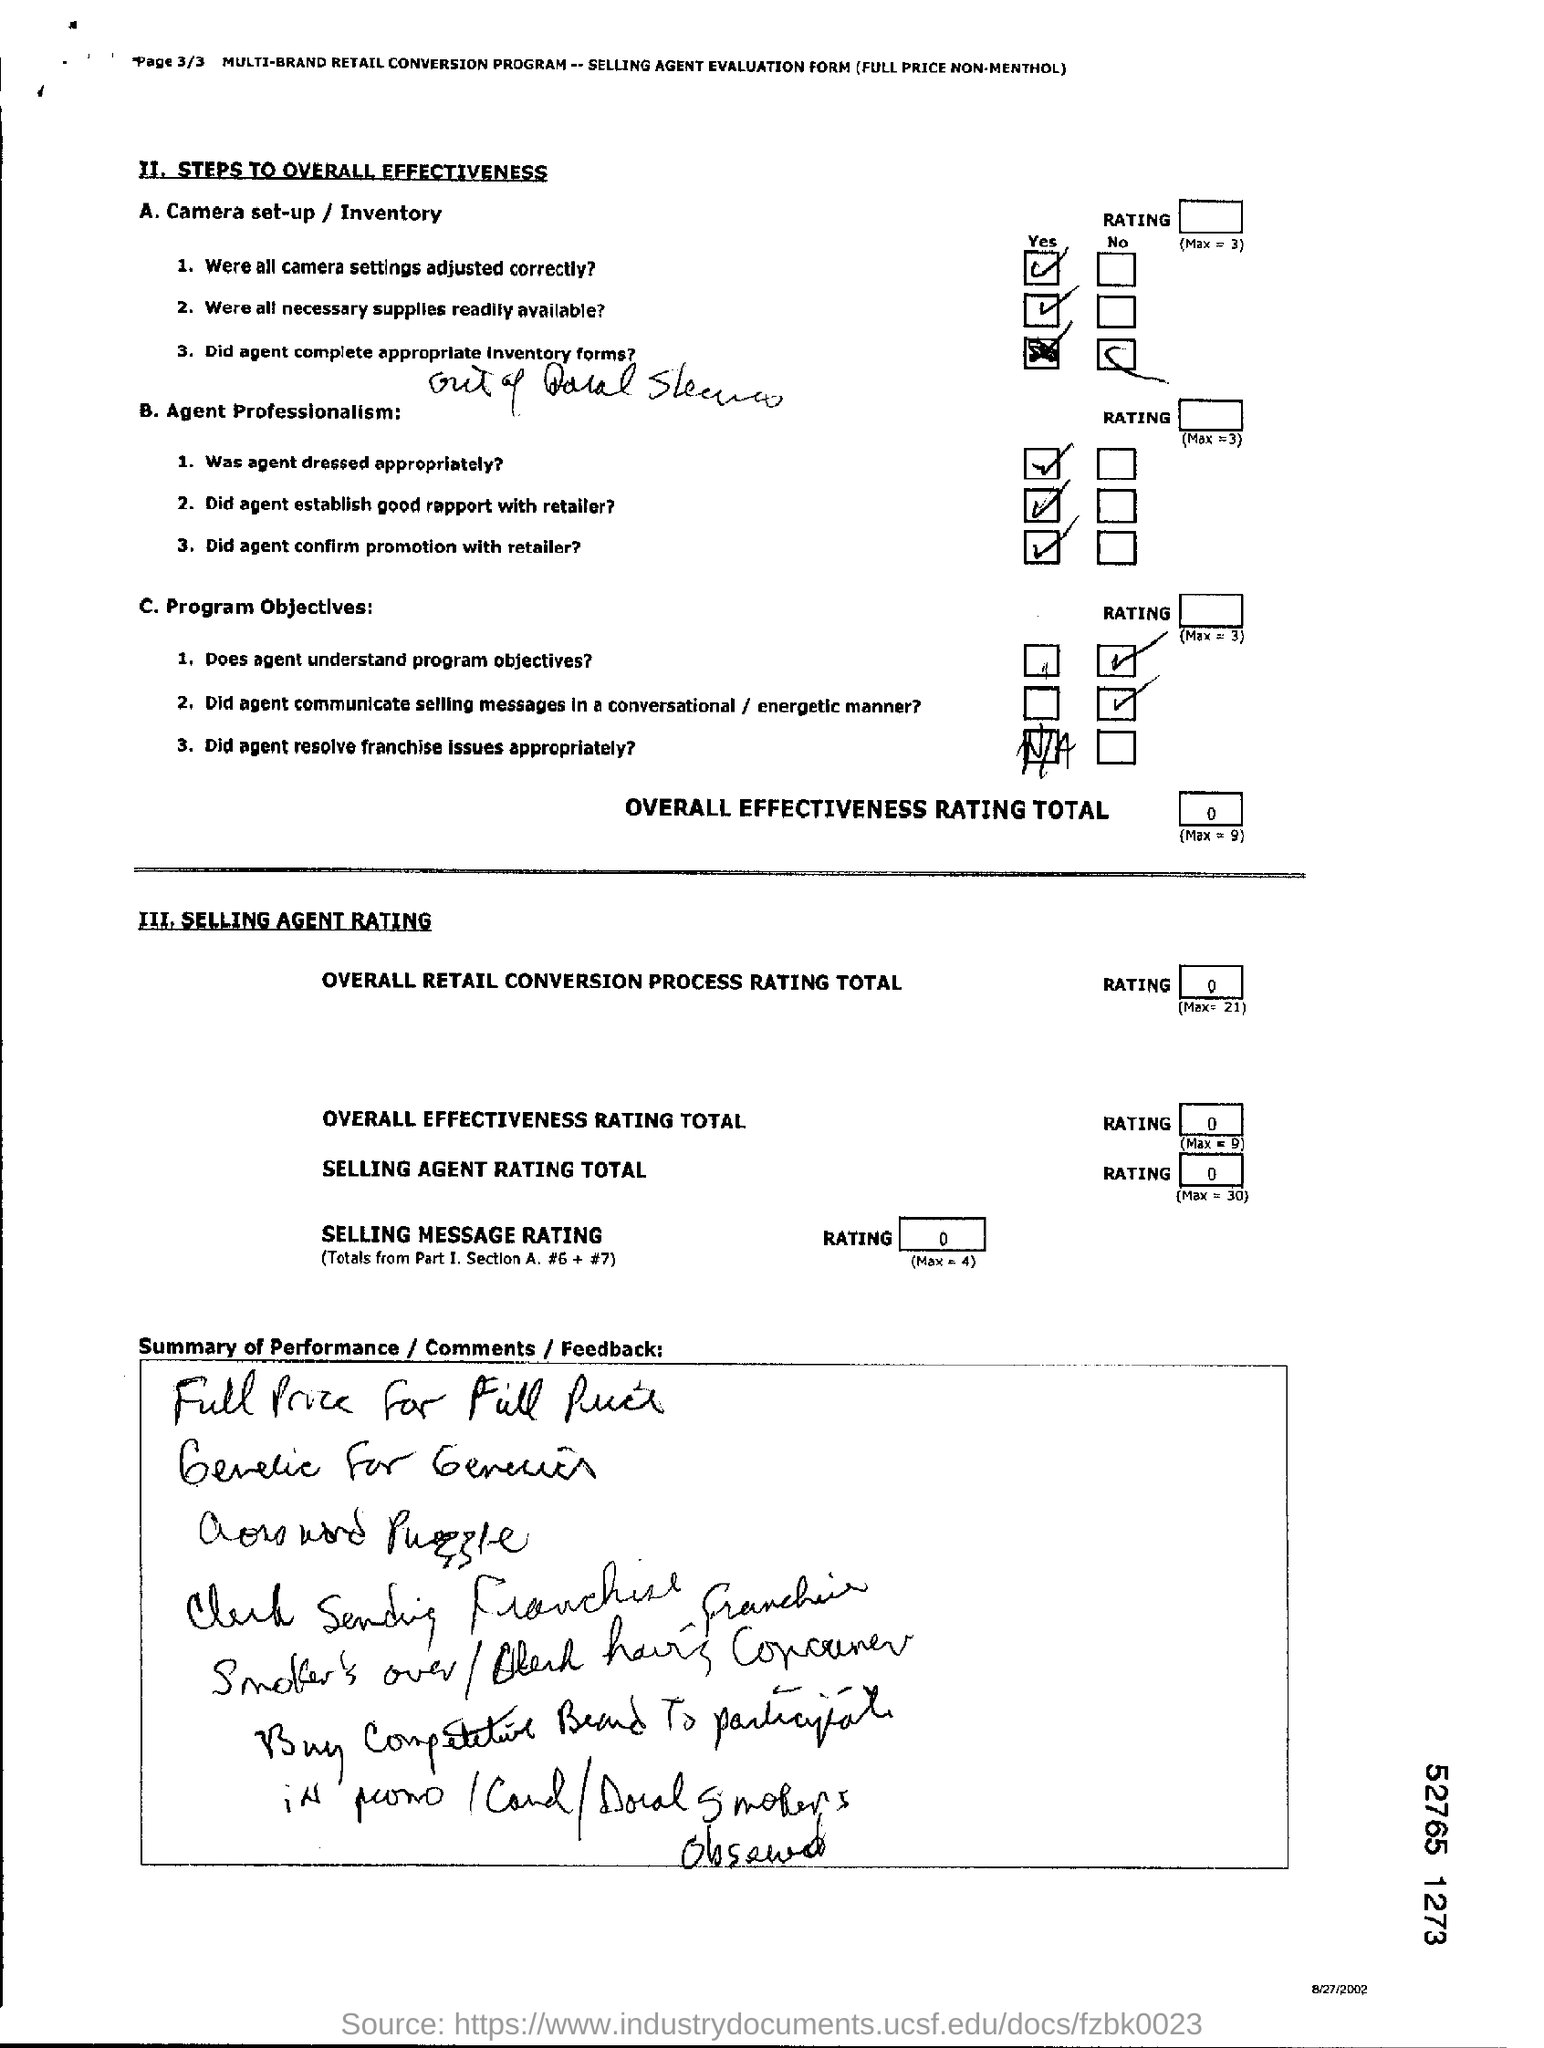Where all camera settings adjusted correctly?
Keep it short and to the point. Yes. Where all necessary suppliers readily available?
Keep it short and to the point. Yes. Does agent understands program objectives?
Make the answer very short. No. 